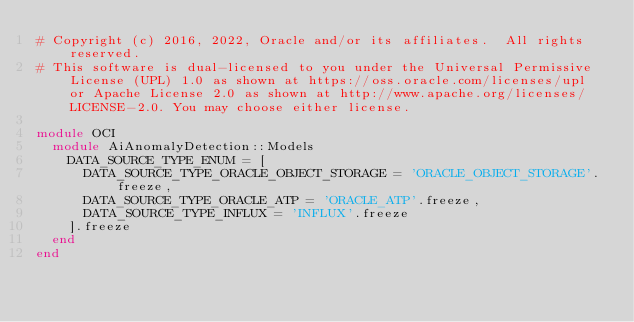Convert code to text. <code><loc_0><loc_0><loc_500><loc_500><_Ruby_># Copyright (c) 2016, 2022, Oracle and/or its affiliates.  All rights reserved.
# This software is dual-licensed to you under the Universal Permissive License (UPL) 1.0 as shown at https://oss.oracle.com/licenses/upl or Apache License 2.0 as shown at http://www.apache.org/licenses/LICENSE-2.0. You may choose either license.

module OCI
  module AiAnomalyDetection::Models
    DATA_SOURCE_TYPE_ENUM = [
      DATA_SOURCE_TYPE_ORACLE_OBJECT_STORAGE = 'ORACLE_OBJECT_STORAGE'.freeze,
      DATA_SOURCE_TYPE_ORACLE_ATP = 'ORACLE_ATP'.freeze,
      DATA_SOURCE_TYPE_INFLUX = 'INFLUX'.freeze
    ].freeze
  end
end
</code> 